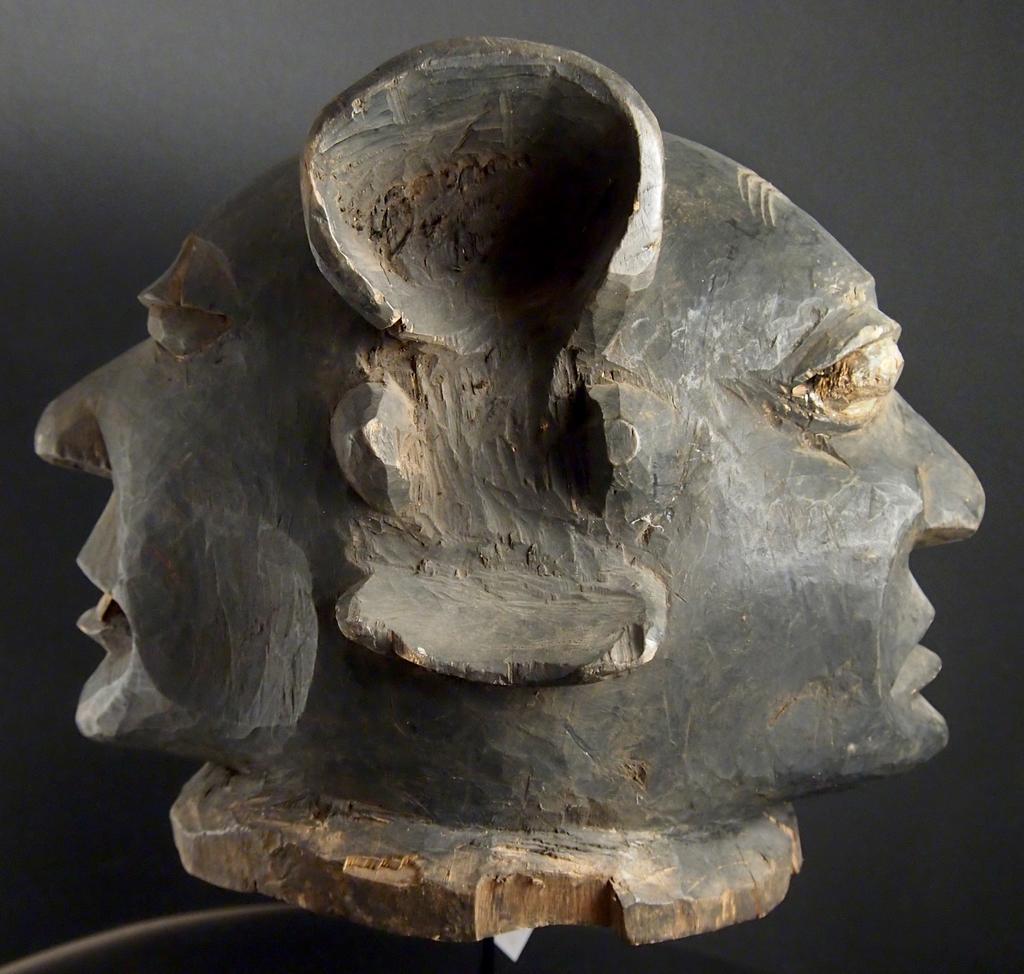In one or two sentences, can you explain what this image depicts? Here we can see a statue and there is a dark background. 